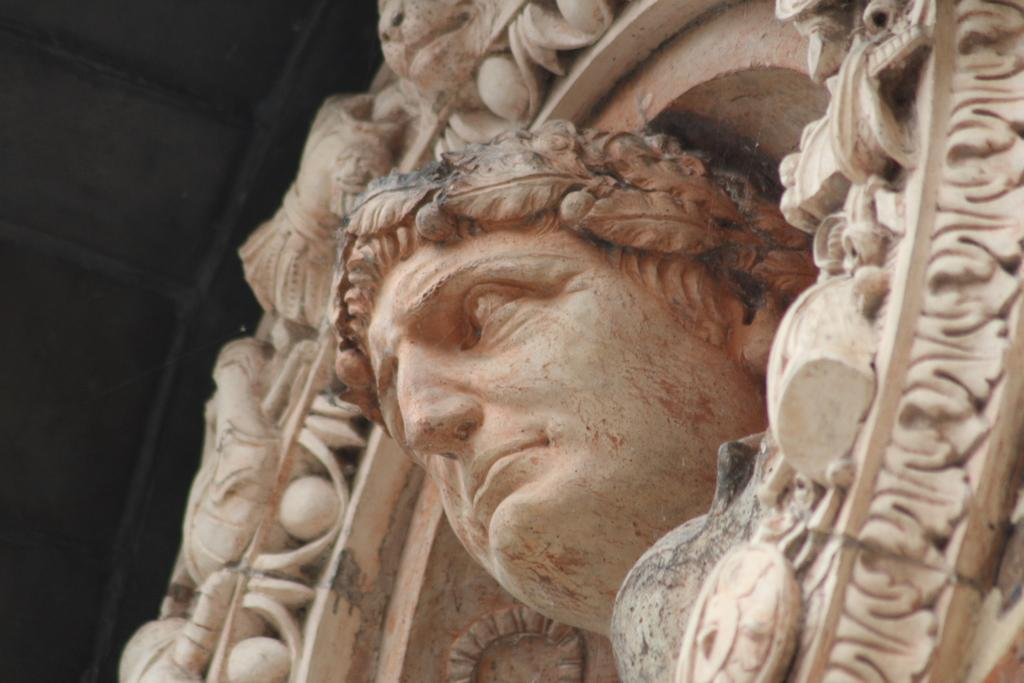What is the main subject of the image? There is a face sculpture in the image. Can you describe the colors of the sculpture? The sculpture is white with some reddish color. Are there any additional features or designs around the sculpture? Yes, there are designs around the sculpture. Can you hear the voice of the sculpture in the image? The sculpture is not capable of producing a voice, as it is an inanimate object. 